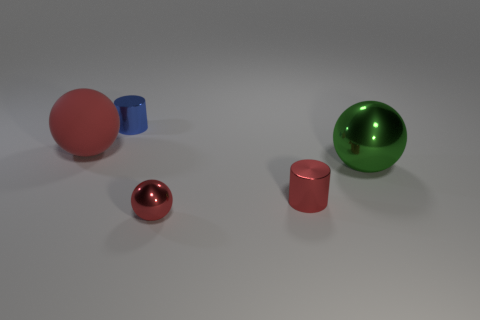Is there any other thing that has the same material as the big red sphere?
Ensure brevity in your answer.  No. How many things are tiny red objects in front of the tiny red metal cylinder or cyan spheres?
Keep it short and to the point. 1. Is the number of big gray rubber objects less than the number of big metal things?
Offer a terse response. Yes. The small object behind the big sphere that is in front of the large red thing behind the tiny red metal cylinder is what shape?
Provide a succinct answer. Cylinder. There is a small shiny object that is the same color as the small metal sphere; what shape is it?
Ensure brevity in your answer.  Cylinder. Are any blue metallic cylinders visible?
Your answer should be very brief. Yes. There is a blue shiny thing; is it the same size as the sphere that is left of the blue cylinder?
Your answer should be compact. No. Are there any tiny metallic things in front of the shiny cylinder that is in front of the small blue cylinder?
Keep it short and to the point. Yes. There is a ball that is both on the left side of the big green ball and in front of the big red object; what material is it?
Ensure brevity in your answer.  Metal. There is a sphere on the left side of the tiny metallic cylinder that is behind the tiny object that is to the right of the tiny sphere; what is its color?
Provide a short and direct response. Red. 